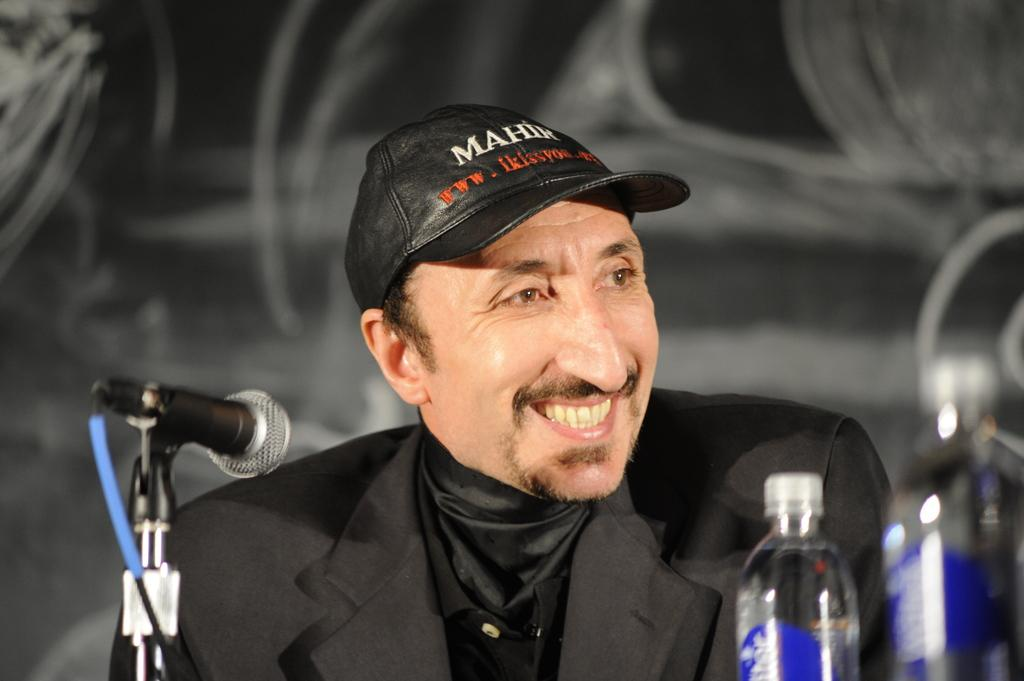Who is present in the image? There is a man in the image. What is the man doing in the image? The man is sitting in the image. What object can be seen near the man? There is a mic in the image. Is there any other object visible in the image? Yes, there is a bottle in the image. What type of farm animals can be seen in the image? There are no farm animals present in the image. What is the structure of the man's hope in the image? The image does not depict the man's hope or any related structure. 